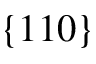<formula> <loc_0><loc_0><loc_500><loc_500>\{ 1 1 0 \}</formula> 